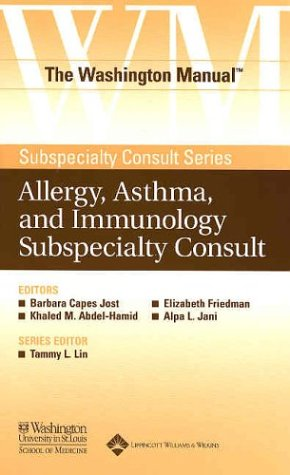What is the title of this book? The full title of the book is 'The Washington Manual® Allergy, Asthma, and Immunology Subspecialty Consult.' This is part of 'The Washington Manual® Subspecialty Consult Series', a well-regarded series of guides in various medical fields. 